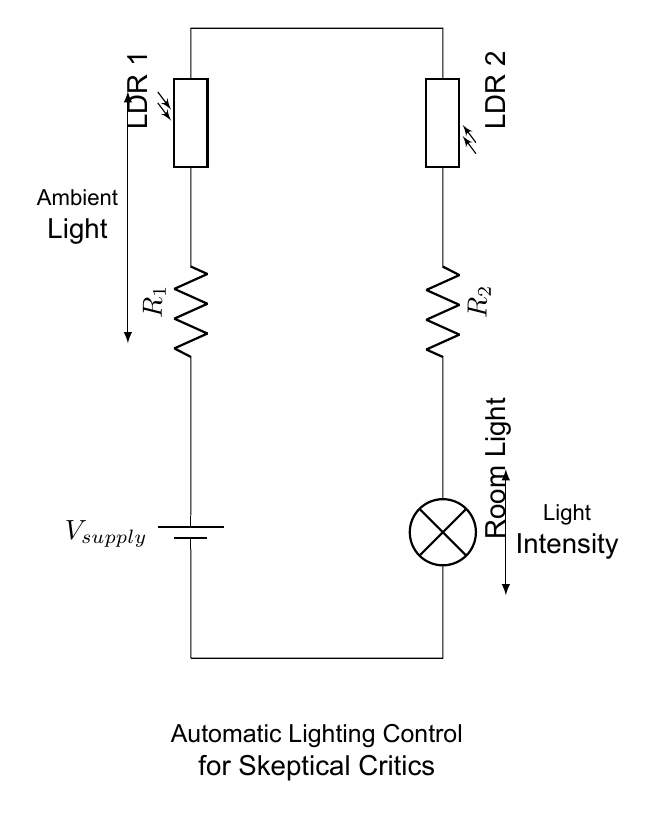What is the power supply voltage? The circuit does not specify a numerical value for the power supply voltage, but it is marked as V_supply, indicating it's the source of electrical power for the circuit.
Answer: V_supply How many resistors are in this circuit? There are two resistors in the circuit, labeled R1 and R2. They are in series with the photoresistors and lamp.
Answer: 2 What component controls the room lighting? The room light component, specifically labeled as "Room Light" in the circuit, is what directly controls the room's lighting based on the ambient light detected.
Answer: Room Light Which components are types of light-dependent resistors? The components labeled LDR 1 and LDR 2 are both types of light-dependent resistors used to sense ambient light levels in the circuit.
Answer: LDR 1 and LDR 2 What happens to the light intensity in dark conditions? In dark conditions, the resistance of the photoresistors (LDR 1 and LDR 2) increases, which would generally cause the lamp to turn on as it is designed to activate when ambient light falls below a certain threshold.
Answer: Lamp turns on Which way is the conventional current direction in this circuit? Conventional current flows from the positive terminal of the battery, through R1, LDR 1, LDR 2, R2, and finally through the lamp before returning to the negative terminal of the battery, following a closed loop.
Answer: From positive to negative What is the function of the photoresistors in this circuit? The photoresistors (LDR 1 and LDR 2) function to detect ambient light levels; their resistance changes with light intensity, which in turn affects the operation of the lamp and serves for automatic lighting control.
Answer: Light detection 